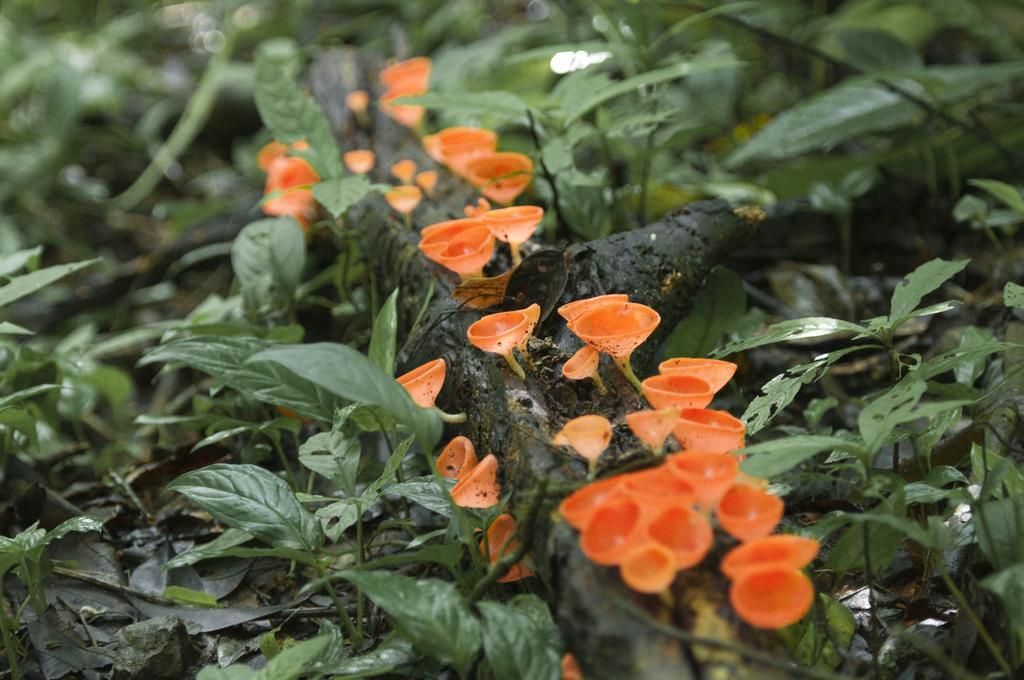How would you summarize this image in a sentence or two? In the picture we can see some plants with a leaf and on it we can see a stem with some flowers to it which are orange in color. 